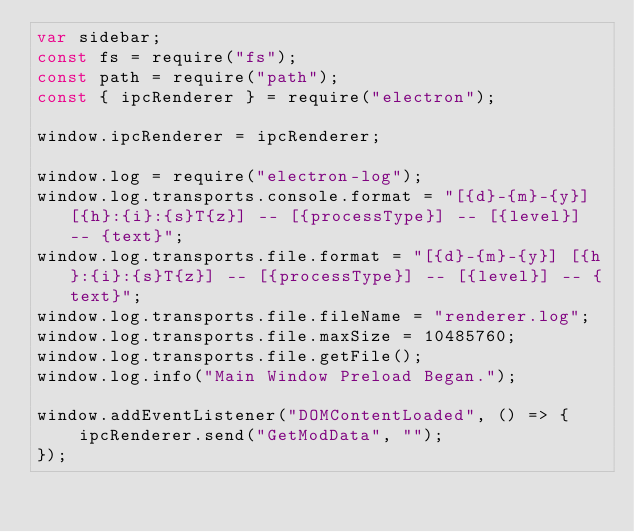<code> <loc_0><loc_0><loc_500><loc_500><_JavaScript_>var sidebar;
const fs = require("fs");
const path = require("path");
const { ipcRenderer } = require("electron");

window.ipcRenderer = ipcRenderer;

window.log = require("electron-log");
window.log.transports.console.format = "[{d}-{m}-{y}] [{h}:{i}:{s}T{z}] -- [{processType}] -- [{level}] -- {text}";
window.log.transports.file.format = "[{d}-{m}-{y}] [{h}:{i}:{s}T{z}] -- [{processType}] -- [{level}] -- {text}";
window.log.transports.file.fileName = "renderer.log";
window.log.transports.file.maxSize = 10485760;
window.log.transports.file.getFile();
window.log.info("Main Window Preload Began.");

window.addEventListener("DOMContentLoaded", () => {
    ipcRenderer.send("GetModData", "");
});
</code> 